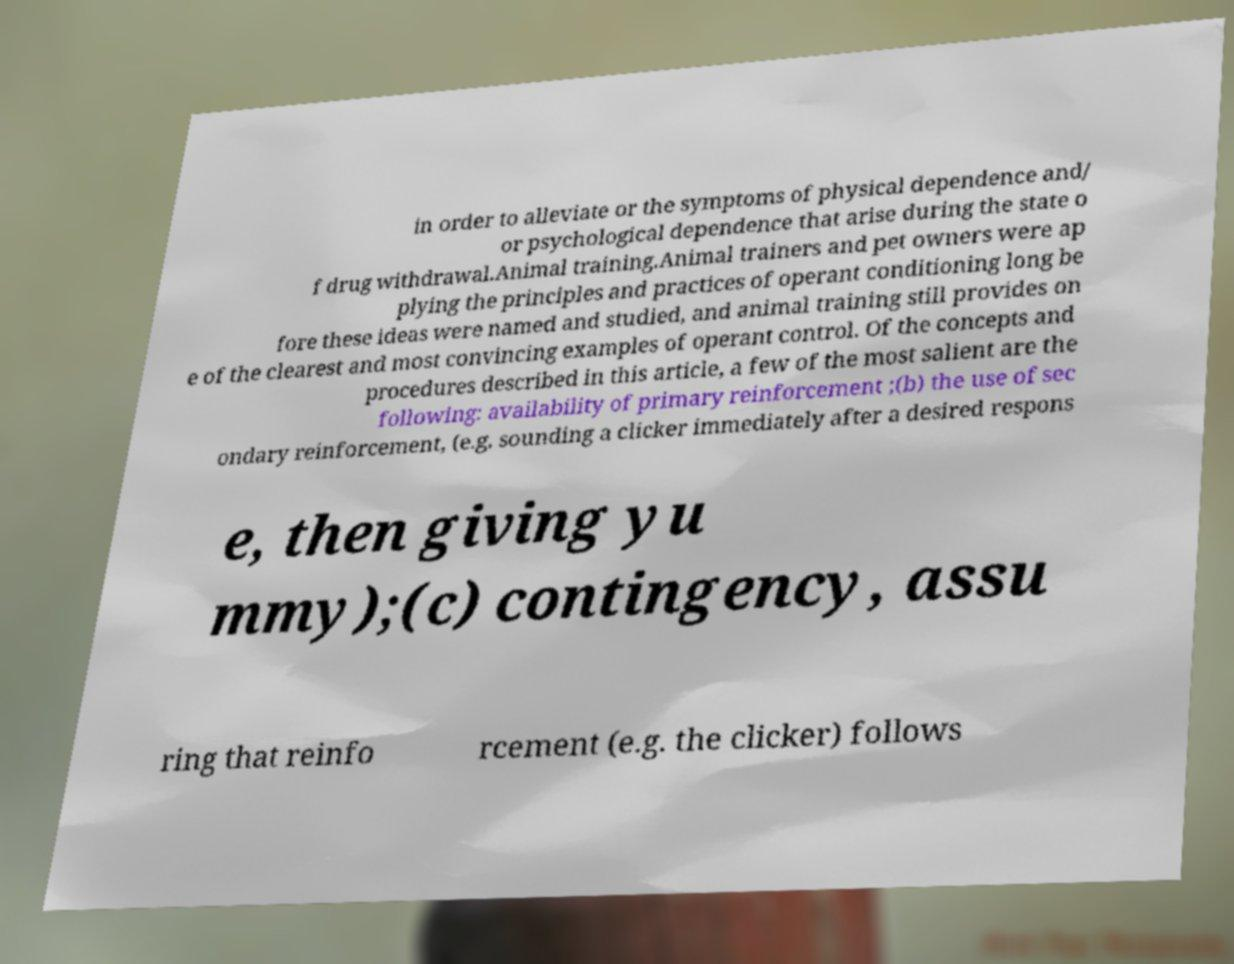Please identify and transcribe the text found in this image. in order to alleviate or the symptoms of physical dependence and/ or psychological dependence that arise during the state o f drug withdrawal.Animal training.Animal trainers and pet owners were ap plying the principles and practices of operant conditioning long be fore these ideas were named and studied, and animal training still provides on e of the clearest and most convincing examples of operant control. Of the concepts and procedures described in this article, a few of the most salient are the following: availability of primary reinforcement ;(b) the use of sec ondary reinforcement, (e.g. sounding a clicker immediately after a desired respons e, then giving yu mmy);(c) contingency, assu ring that reinfo rcement (e.g. the clicker) follows 